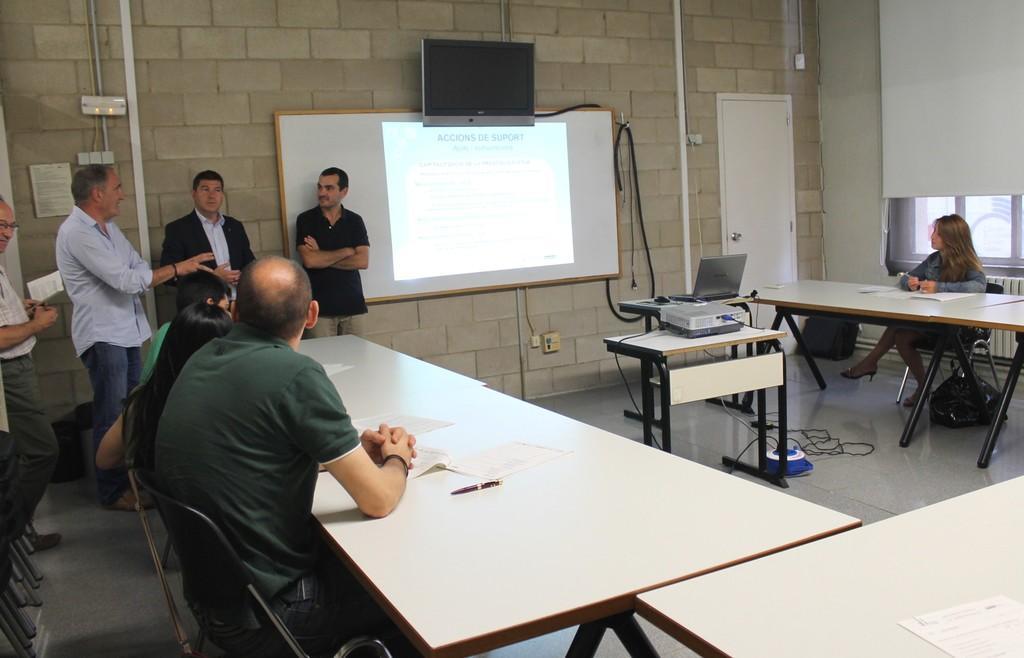Please provide a concise description of this image. Here we can see some persons are sitting on the chairs. These are the tables. On the table there are papers and a projector. This is a laptop. Here we can see some persons are standing on the floor. There is a door and this is screen. On the background there is a wall. 